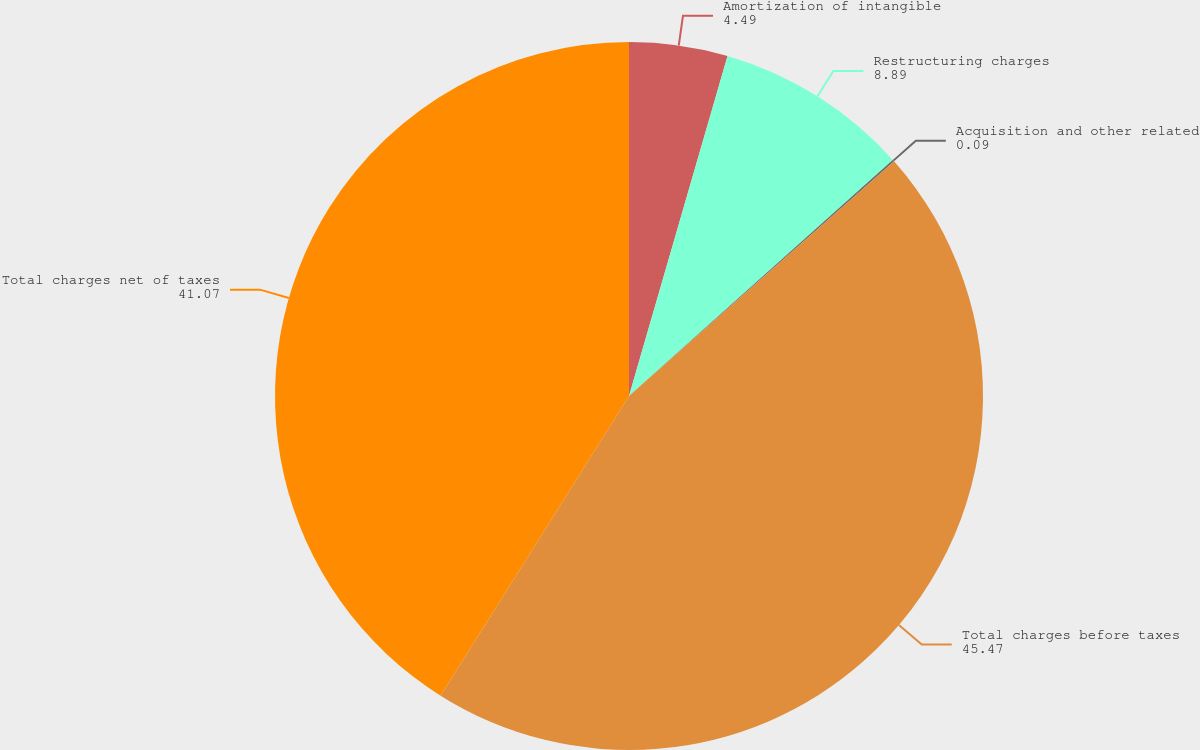Convert chart to OTSL. <chart><loc_0><loc_0><loc_500><loc_500><pie_chart><fcel>Amortization of intangible<fcel>Restructuring charges<fcel>Acquisition and other related<fcel>Total charges before taxes<fcel>Total charges net of taxes<nl><fcel>4.49%<fcel>8.89%<fcel>0.09%<fcel>45.47%<fcel>41.07%<nl></chart> 